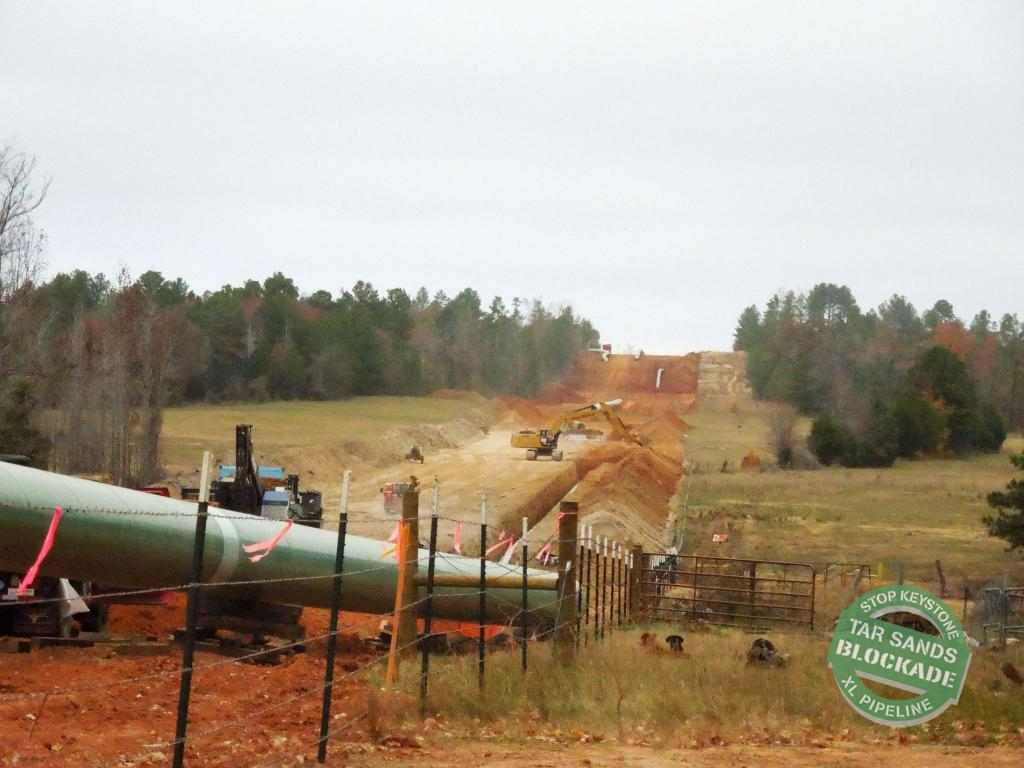What types of objects can be seen in the image? There are vehicles in the image. What structures are present in the image? There is a fence in the image. What type of vegetation is visible in the image? There are trees, plants, and grass in the image. What type of terrain is present in the image? There is sand in the image. What is visible in the background of the image? The sky is visible in the background of the image. What time is displayed on the clock in the image? There is no clock present in the image. What type of stem can be seen growing from the sand in the image? There are no stems growing from the sand in the image. 